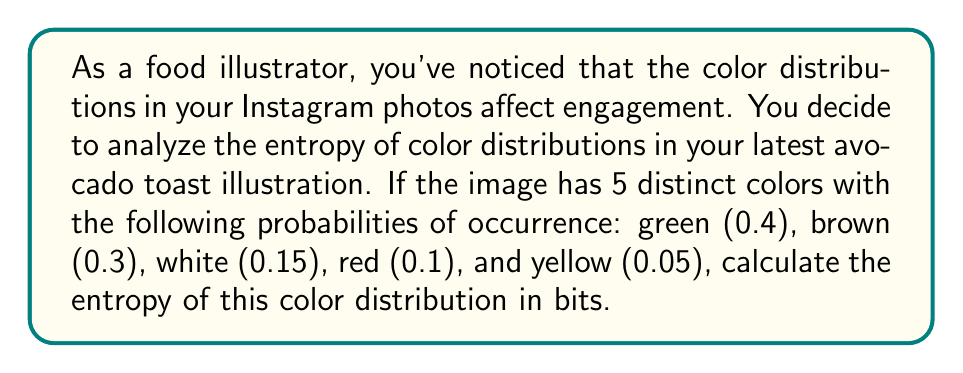Show me your answer to this math problem. To calculate the entropy of the color distribution, we'll use the formula for Shannon entropy:

$$H = -\sum_{i=1}^n p_i \log_2(p_i)$$

Where $H$ is the entropy, $p_i$ is the probability of each color, and $n$ is the number of distinct colors.

Let's calculate the entropy for each color:

1. Green: $-0.4 \log_2(0.4)$
2. Brown: $-0.3 \log_2(0.3)$
3. White: $-0.15 \log_2(0.15)$
4. Red: $-0.1 \log_2(0.1)$
5. Yellow: $-0.05 \log_2(0.05)$

Now, let's sum these values:

$$\begin{align}
H &= -0.4 \log_2(0.4) - 0.3 \log_2(0.3) - 0.15 \log_2(0.15) - 0.1 \log_2(0.1) - 0.05 \log_2(0.05) \\
&= 0.528771 + 0.521436 + 0.410944 + 0.332193 + 0.216096 \\
&= 2.00944
\end{align}$$

The result is approximately 2.01 bits.
Answer: The entropy of the color distribution is approximately 2.01 bits. 